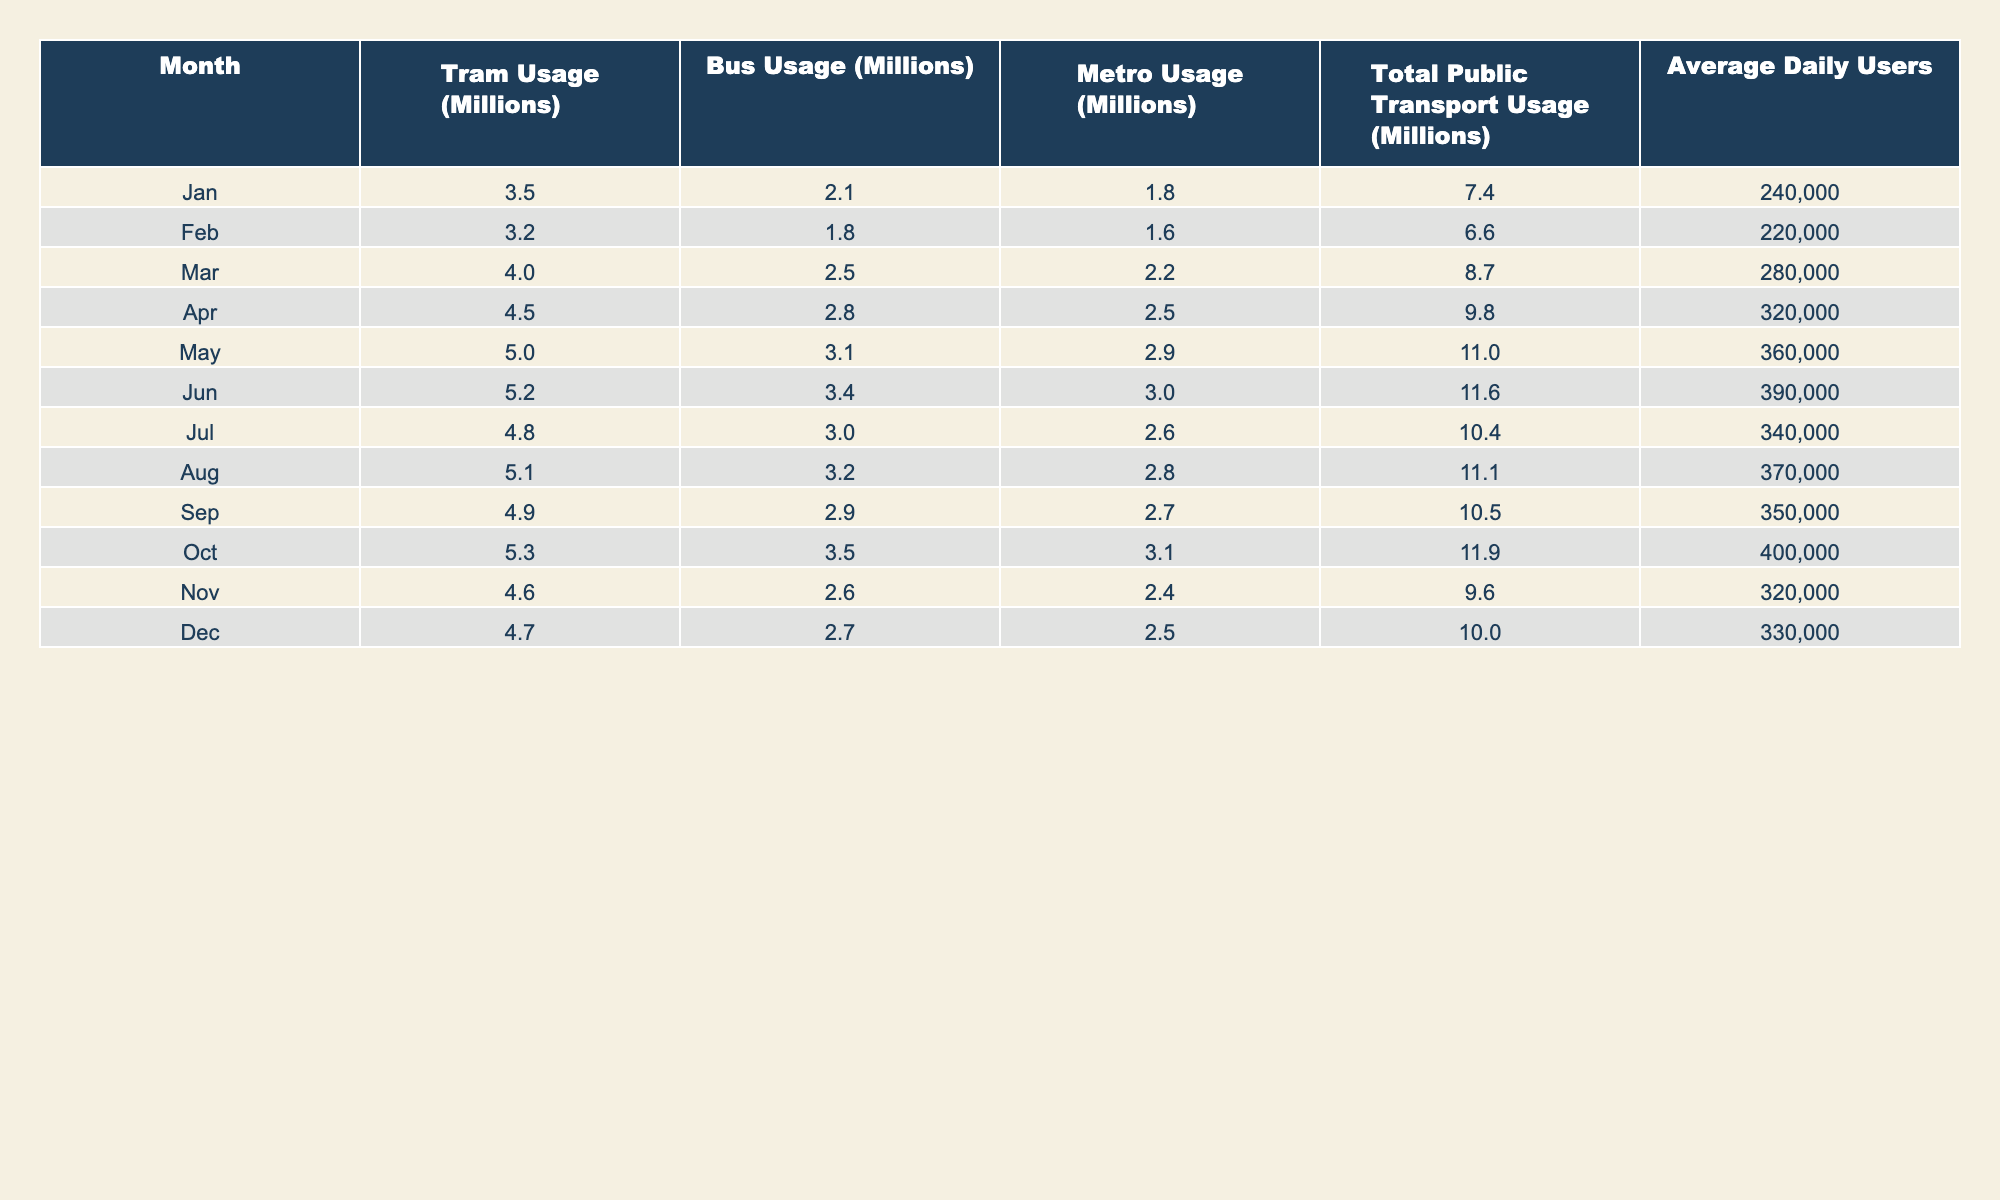What was the total public transport usage in August? In August, the total public transport usage is listed as 11.1 million.
Answer: 11.1 million Which month had the highest tram usage? The highest tram usage is in May, with 5.0 million.
Answer: May What is the average number of daily users in March? The average daily users in March is 280,000, as mentioned in the table.
Answer: 280,000 How much did metro usage increase from January to April? Metro usage in January was 1.8 million and in April it was 2.5 million. The increase is 2.5 - 1.8 = 0.7 million.
Answer: 0.7 million What was the total public transport usage in the second half of the year compared to the first half? First half: (7.4 + 6.6 + 8.7 + 9.8 + 11.0 + 11.6) = 55.1 million. Second half: (10.4 + 11.1 + 10.5 + 11.9 + 9.6 + 10.0) = 63.5 million. Second half total is 63.5 million, which is greater than the first half total of 55.1 million.
Answer: Second half is greater Was there a month where the average daily users exceeded 400,000? The data shows that the highest average daily users is 400,000 in October; therefore, there was no month with more than that.
Answer: No What month had both the highest tram and bus usage combined? May had tram usage of 5.0 million and bus usage of 3.1 million, which totals 8.1 million, higher than any other month.
Answer: May Which month had the lowest total public transport usage? The month with the lowest total public transport usage is February, at 6.6 million.
Answer: February How much more regular bus users were there in June compared to January? Bus usage in January was 2.1 million and in June it was 3.4 million. The difference is 3.4 - 2.1 = 1.3 million users.
Answer: 1.3 million Is it true that every month in the table has a total public transport usage of at least 6 million? By inspecting the table, all months report total usage of at least 6 million; February is the lowest at 6.6 million. Thus, the statement is true.
Answer: Yes In which month did the average daily users first exceed 300,000? The first month to exceed 300,000 average daily users is April, with 320,000 users.
Answer: April 